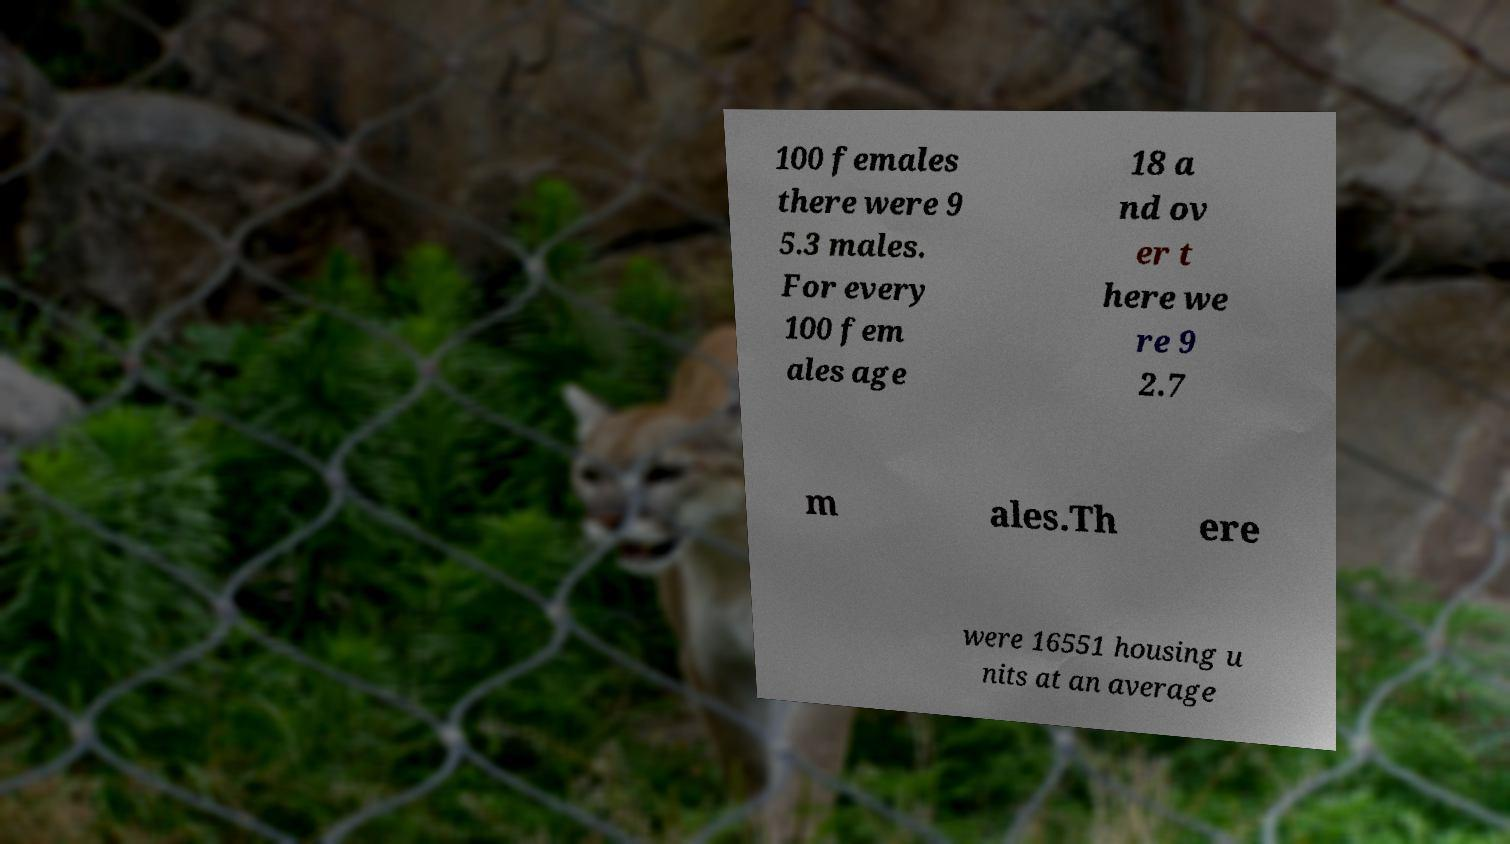What messages or text are displayed in this image? I need them in a readable, typed format. 100 females there were 9 5.3 males. For every 100 fem ales age 18 a nd ov er t here we re 9 2.7 m ales.Th ere were 16551 housing u nits at an average 